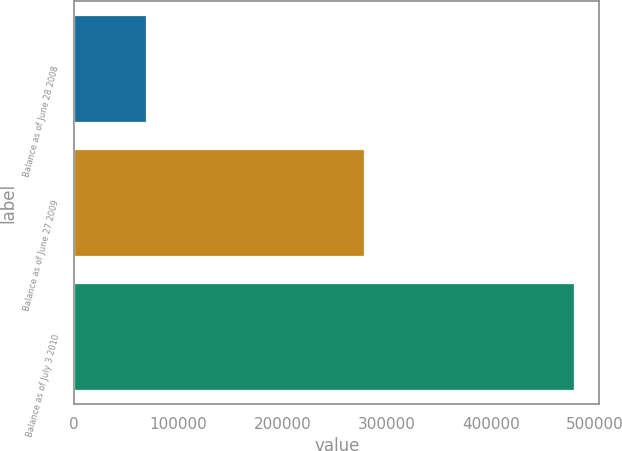Convert chart. <chart><loc_0><loc_0><loc_500><loc_500><bar_chart><fcel>Balance as of June 28 2008<fcel>Balance as of June 27 2009<fcel>Balance as of July 3 2010<nl><fcel>68768<fcel>277986<fcel>480251<nl></chart> 